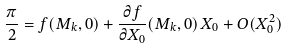Convert formula to latex. <formula><loc_0><loc_0><loc_500><loc_500>\frac { \pi } { 2 } = f ( M _ { k } , 0 ) + \frac { \partial f } { \partial X _ { 0 } } ( M _ { k } , 0 ) \, X _ { 0 } + O ( X _ { 0 } ^ { 2 } )</formula> 